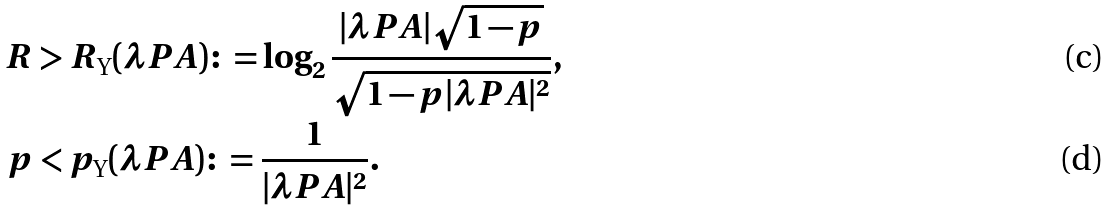<formula> <loc_0><loc_0><loc_500><loc_500>R & > R _ { \text {Y} } ( \lambda P A ) \colon = \log _ { 2 } \frac { | \lambda P A | \sqrt { 1 - p } } { \sqrt { 1 - p | \lambda P A | ^ { 2 } } } , \\ p & < p _ { \text {Y} } ( \lambda P A ) \colon = \frac { 1 } { | \lambda P A | ^ { 2 } } .</formula> 